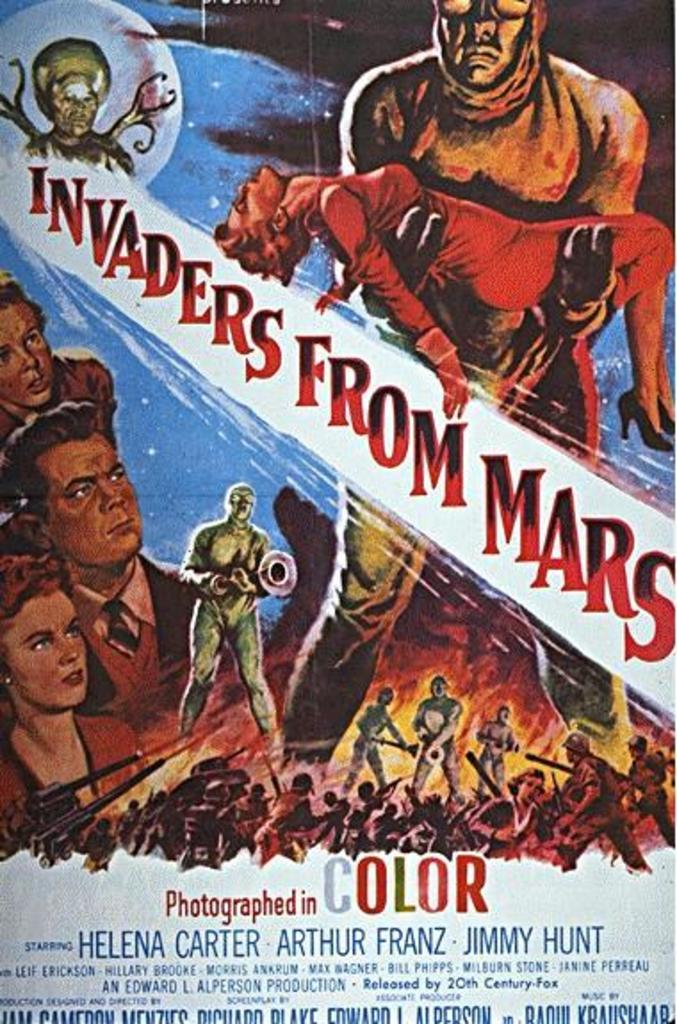<image>
Offer a succinct explanation of the picture presented. a movie potser of the invaders from mars staring helen carter 